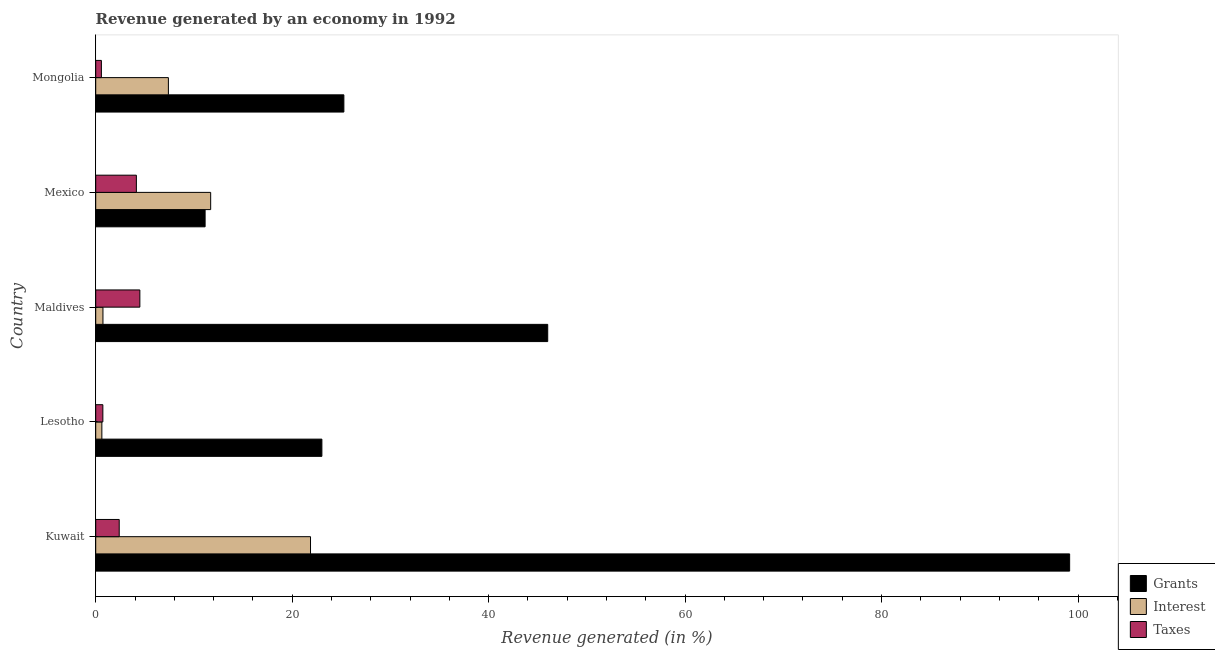How many different coloured bars are there?
Make the answer very short. 3. How many bars are there on the 5th tick from the top?
Your answer should be very brief. 3. How many bars are there on the 5th tick from the bottom?
Offer a terse response. 3. What is the percentage of revenue generated by interest in Lesotho?
Offer a terse response. 0.63. Across all countries, what is the maximum percentage of revenue generated by taxes?
Offer a terse response. 4.49. Across all countries, what is the minimum percentage of revenue generated by taxes?
Keep it short and to the point. 0.58. In which country was the percentage of revenue generated by grants maximum?
Your answer should be very brief. Kuwait. In which country was the percentage of revenue generated by interest minimum?
Your response must be concise. Lesotho. What is the total percentage of revenue generated by taxes in the graph?
Provide a short and direct response. 12.33. What is the difference between the percentage of revenue generated by taxes in Lesotho and that in Maldives?
Your answer should be very brief. -3.77. What is the difference between the percentage of revenue generated by taxes in Kuwait and the percentage of revenue generated by interest in Maldives?
Your answer should be compact. 1.66. What is the average percentage of revenue generated by interest per country?
Give a very brief answer. 8.47. What is the difference between the percentage of revenue generated by interest and percentage of revenue generated by taxes in Maldives?
Your answer should be very brief. -3.76. Is the difference between the percentage of revenue generated by grants in Mexico and Mongolia greater than the difference between the percentage of revenue generated by taxes in Mexico and Mongolia?
Your response must be concise. No. What is the difference between the highest and the second highest percentage of revenue generated by interest?
Offer a very short reply. 10.16. What is the difference between the highest and the lowest percentage of revenue generated by grants?
Give a very brief answer. 88.01. Is the sum of the percentage of revenue generated by grants in Lesotho and Mexico greater than the maximum percentage of revenue generated by taxes across all countries?
Provide a succinct answer. Yes. What does the 1st bar from the top in Kuwait represents?
Offer a very short reply. Taxes. What does the 1st bar from the bottom in Mongolia represents?
Offer a very short reply. Grants. How many bars are there?
Offer a very short reply. 15. Are all the bars in the graph horizontal?
Your response must be concise. Yes. How many countries are there in the graph?
Provide a succinct answer. 5. What is the difference between two consecutive major ticks on the X-axis?
Offer a terse response. 20. Are the values on the major ticks of X-axis written in scientific E-notation?
Ensure brevity in your answer.  No. Does the graph contain any zero values?
Make the answer very short. No. How many legend labels are there?
Provide a short and direct response. 3. What is the title of the graph?
Your answer should be very brief. Revenue generated by an economy in 1992. What is the label or title of the X-axis?
Keep it short and to the point. Revenue generated (in %). What is the Revenue generated (in %) in Grants in Kuwait?
Keep it short and to the point. 99.15. What is the Revenue generated (in %) in Interest in Kuwait?
Make the answer very short. 21.87. What is the Revenue generated (in %) of Taxes in Kuwait?
Make the answer very short. 2.39. What is the Revenue generated (in %) in Grants in Lesotho?
Give a very brief answer. 23.02. What is the Revenue generated (in %) of Interest in Lesotho?
Make the answer very short. 0.63. What is the Revenue generated (in %) in Taxes in Lesotho?
Give a very brief answer. 0.73. What is the Revenue generated (in %) of Grants in Maldives?
Keep it short and to the point. 46.01. What is the Revenue generated (in %) in Interest in Maldives?
Your answer should be compact. 0.74. What is the Revenue generated (in %) in Taxes in Maldives?
Ensure brevity in your answer.  4.49. What is the Revenue generated (in %) in Grants in Mexico?
Give a very brief answer. 11.14. What is the Revenue generated (in %) of Interest in Mexico?
Your response must be concise. 11.7. What is the Revenue generated (in %) in Taxes in Mexico?
Your answer should be very brief. 4.14. What is the Revenue generated (in %) in Grants in Mongolia?
Provide a succinct answer. 25.26. What is the Revenue generated (in %) in Interest in Mongolia?
Keep it short and to the point. 7.4. What is the Revenue generated (in %) of Taxes in Mongolia?
Keep it short and to the point. 0.58. Across all countries, what is the maximum Revenue generated (in %) of Grants?
Provide a short and direct response. 99.15. Across all countries, what is the maximum Revenue generated (in %) in Interest?
Provide a succinct answer. 21.87. Across all countries, what is the maximum Revenue generated (in %) in Taxes?
Provide a short and direct response. 4.49. Across all countries, what is the minimum Revenue generated (in %) in Grants?
Offer a terse response. 11.14. Across all countries, what is the minimum Revenue generated (in %) of Interest?
Your answer should be very brief. 0.63. Across all countries, what is the minimum Revenue generated (in %) of Taxes?
Offer a terse response. 0.58. What is the total Revenue generated (in %) in Grants in the graph?
Your answer should be compact. 204.58. What is the total Revenue generated (in %) in Interest in the graph?
Your answer should be very brief. 42.33. What is the total Revenue generated (in %) of Taxes in the graph?
Provide a short and direct response. 12.33. What is the difference between the Revenue generated (in %) in Grants in Kuwait and that in Lesotho?
Your answer should be compact. 76.12. What is the difference between the Revenue generated (in %) of Interest in Kuwait and that in Lesotho?
Give a very brief answer. 21.24. What is the difference between the Revenue generated (in %) of Taxes in Kuwait and that in Lesotho?
Provide a short and direct response. 1.67. What is the difference between the Revenue generated (in %) of Grants in Kuwait and that in Maldives?
Your response must be concise. 53.13. What is the difference between the Revenue generated (in %) of Interest in Kuwait and that in Maldives?
Offer a terse response. 21.13. What is the difference between the Revenue generated (in %) in Taxes in Kuwait and that in Maldives?
Keep it short and to the point. -2.1. What is the difference between the Revenue generated (in %) of Grants in Kuwait and that in Mexico?
Ensure brevity in your answer.  88.01. What is the difference between the Revenue generated (in %) in Interest in Kuwait and that in Mexico?
Your response must be concise. 10.16. What is the difference between the Revenue generated (in %) of Taxes in Kuwait and that in Mexico?
Provide a short and direct response. -1.75. What is the difference between the Revenue generated (in %) in Grants in Kuwait and that in Mongolia?
Offer a terse response. 73.88. What is the difference between the Revenue generated (in %) of Interest in Kuwait and that in Mongolia?
Make the answer very short. 14.47. What is the difference between the Revenue generated (in %) in Taxes in Kuwait and that in Mongolia?
Give a very brief answer. 1.82. What is the difference between the Revenue generated (in %) in Grants in Lesotho and that in Maldives?
Your answer should be very brief. -22.99. What is the difference between the Revenue generated (in %) of Interest in Lesotho and that in Maldives?
Keep it short and to the point. -0.11. What is the difference between the Revenue generated (in %) in Taxes in Lesotho and that in Maldives?
Keep it short and to the point. -3.77. What is the difference between the Revenue generated (in %) in Grants in Lesotho and that in Mexico?
Make the answer very short. 11.89. What is the difference between the Revenue generated (in %) of Interest in Lesotho and that in Mexico?
Ensure brevity in your answer.  -11.08. What is the difference between the Revenue generated (in %) in Taxes in Lesotho and that in Mexico?
Offer a terse response. -3.41. What is the difference between the Revenue generated (in %) of Grants in Lesotho and that in Mongolia?
Offer a very short reply. -2.24. What is the difference between the Revenue generated (in %) in Interest in Lesotho and that in Mongolia?
Make the answer very short. -6.77. What is the difference between the Revenue generated (in %) in Taxes in Lesotho and that in Mongolia?
Make the answer very short. 0.15. What is the difference between the Revenue generated (in %) in Grants in Maldives and that in Mexico?
Your response must be concise. 34.88. What is the difference between the Revenue generated (in %) of Interest in Maldives and that in Mexico?
Your answer should be very brief. -10.96. What is the difference between the Revenue generated (in %) of Taxes in Maldives and that in Mexico?
Your answer should be very brief. 0.36. What is the difference between the Revenue generated (in %) of Grants in Maldives and that in Mongolia?
Give a very brief answer. 20.75. What is the difference between the Revenue generated (in %) in Interest in Maldives and that in Mongolia?
Your answer should be very brief. -6.66. What is the difference between the Revenue generated (in %) of Taxes in Maldives and that in Mongolia?
Your answer should be very brief. 3.92. What is the difference between the Revenue generated (in %) of Grants in Mexico and that in Mongolia?
Provide a short and direct response. -14.13. What is the difference between the Revenue generated (in %) of Interest in Mexico and that in Mongolia?
Your answer should be very brief. 4.3. What is the difference between the Revenue generated (in %) of Taxes in Mexico and that in Mongolia?
Your response must be concise. 3.56. What is the difference between the Revenue generated (in %) of Grants in Kuwait and the Revenue generated (in %) of Interest in Lesotho?
Your answer should be very brief. 98.52. What is the difference between the Revenue generated (in %) in Grants in Kuwait and the Revenue generated (in %) in Taxes in Lesotho?
Offer a terse response. 98.42. What is the difference between the Revenue generated (in %) of Interest in Kuwait and the Revenue generated (in %) of Taxes in Lesotho?
Ensure brevity in your answer.  21.14. What is the difference between the Revenue generated (in %) of Grants in Kuwait and the Revenue generated (in %) of Interest in Maldives?
Give a very brief answer. 98.41. What is the difference between the Revenue generated (in %) of Grants in Kuwait and the Revenue generated (in %) of Taxes in Maldives?
Offer a very short reply. 94.65. What is the difference between the Revenue generated (in %) in Interest in Kuwait and the Revenue generated (in %) in Taxes in Maldives?
Your answer should be very brief. 17.37. What is the difference between the Revenue generated (in %) in Grants in Kuwait and the Revenue generated (in %) in Interest in Mexico?
Offer a terse response. 87.44. What is the difference between the Revenue generated (in %) in Grants in Kuwait and the Revenue generated (in %) in Taxes in Mexico?
Keep it short and to the point. 95.01. What is the difference between the Revenue generated (in %) of Interest in Kuwait and the Revenue generated (in %) of Taxes in Mexico?
Keep it short and to the point. 17.73. What is the difference between the Revenue generated (in %) of Grants in Kuwait and the Revenue generated (in %) of Interest in Mongolia?
Keep it short and to the point. 91.75. What is the difference between the Revenue generated (in %) of Grants in Kuwait and the Revenue generated (in %) of Taxes in Mongolia?
Provide a short and direct response. 98.57. What is the difference between the Revenue generated (in %) in Interest in Kuwait and the Revenue generated (in %) in Taxes in Mongolia?
Ensure brevity in your answer.  21.29. What is the difference between the Revenue generated (in %) of Grants in Lesotho and the Revenue generated (in %) of Interest in Maldives?
Offer a terse response. 22.29. What is the difference between the Revenue generated (in %) in Grants in Lesotho and the Revenue generated (in %) in Taxes in Maldives?
Provide a short and direct response. 18.53. What is the difference between the Revenue generated (in %) of Interest in Lesotho and the Revenue generated (in %) of Taxes in Maldives?
Offer a terse response. -3.87. What is the difference between the Revenue generated (in %) in Grants in Lesotho and the Revenue generated (in %) in Interest in Mexico?
Give a very brief answer. 11.32. What is the difference between the Revenue generated (in %) in Grants in Lesotho and the Revenue generated (in %) in Taxes in Mexico?
Ensure brevity in your answer.  18.89. What is the difference between the Revenue generated (in %) in Interest in Lesotho and the Revenue generated (in %) in Taxes in Mexico?
Make the answer very short. -3.51. What is the difference between the Revenue generated (in %) of Grants in Lesotho and the Revenue generated (in %) of Interest in Mongolia?
Offer a terse response. 15.63. What is the difference between the Revenue generated (in %) of Grants in Lesotho and the Revenue generated (in %) of Taxes in Mongolia?
Ensure brevity in your answer.  22.45. What is the difference between the Revenue generated (in %) of Interest in Lesotho and the Revenue generated (in %) of Taxes in Mongolia?
Give a very brief answer. 0.05. What is the difference between the Revenue generated (in %) of Grants in Maldives and the Revenue generated (in %) of Interest in Mexico?
Offer a very short reply. 34.31. What is the difference between the Revenue generated (in %) in Grants in Maldives and the Revenue generated (in %) in Taxes in Mexico?
Ensure brevity in your answer.  41.88. What is the difference between the Revenue generated (in %) of Interest in Maldives and the Revenue generated (in %) of Taxes in Mexico?
Provide a short and direct response. -3.4. What is the difference between the Revenue generated (in %) in Grants in Maldives and the Revenue generated (in %) in Interest in Mongolia?
Keep it short and to the point. 38.62. What is the difference between the Revenue generated (in %) in Grants in Maldives and the Revenue generated (in %) in Taxes in Mongolia?
Give a very brief answer. 45.44. What is the difference between the Revenue generated (in %) in Interest in Maldives and the Revenue generated (in %) in Taxes in Mongolia?
Provide a short and direct response. 0.16. What is the difference between the Revenue generated (in %) of Grants in Mexico and the Revenue generated (in %) of Interest in Mongolia?
Provide a succinct answer. 3.74. What is the difference between the Revenue generated (in %) of Grants in Mexico and the Revenue generated (in %) of Taxes in Mongolia?
Ensure brevity in your answer.  10.56. What is the difference between the Revenue generated (in %) of Interest in Mexico and the Revenue generated (in %) of Taxes in Mongolia?
Your answer should be very brief. 11.12. What is the average Revenue generated (in %) of Grants per country?
Your answer should be compact. 40.92. What is the average Revenue generated (in %) in Interest per country?
Your answer should be compact. 8.47. What is the average Revenue generated (in %) of Taxes per country?
Your response must be concise. 2.47. What is the difference between the Revenue generated (in %) of Grants and Revenue generated (in %) of Interest in Kuwait?
Provide a short and direct response. 77.28. What is the difference between the Revenue generated (in %) of Grants and Revenue generated (in %) of Taxes in Kuwait?
Provide a succinct answer. 96.75. What is the difference between the Revenue generated (in %) of Interest and Revenue generated (in %) of Taxes in Kuwait?
Ensure brevity in your answer.  19.47. What is the difference between the Revenue generated (in %) in Grants and Revenue generated (in %) in Interest in Lesotho?
Your response must be concise. 22.4. What is the difference between the Revenue generated (in %) of Grants and Revenue generated (in %) of Taxes in Lesotho?
Keep it short and to the point. 22.3. What is the difference between the Revenue generated (in %) in Interest and Revenue generated (in %) in Taxes in Lesotho?
Your answer should be compact. -0.1. What is the difference between the Revenue generated (in %) of Grants and Revenue generated (in %) of Interest in Maldives?
Your answer should be very brief. 45.28. What is the difference between the Revenue generated (in %) in Grants and Revenue generated (in %) in Taxes in Maldives?
Offer a very short reply. 41.52. What is the difference between the Revenue generated (in %) of Interest and Revenue generated (in %) of Taxes in Maldives?
Offer a very short reply. -3.76. What is the difference between the Revenue generated (in %) of Grants and Revenue generated (in %) of Interest in Mexico?
Give a very brief answer. -0.57. What is the difference between the Revenue generated (in %) of Grants and Revenue generated (in %) of Taxes in Mexico?
Provide a succinct answer. 7. What is the difference between the Revenue generated (in %) in Interest and Revenue generated (in %) in Taxes in Mexico?
Give a very brief answer. 7.56. What is the difference between the Revenue generated (in %) of Grants and Revenue generated (in %) of Interest in Mongolia?
Provide a succinct answer. 17.86. What is the difference between the Revenue generated (in %) of Grants and Revenue generated (in %) of Taxes in Mongolia?
Your response must be concise. 24.68. What is the difference between the Revenue generated (in %) of Interest and Revenue generated (in %) of Taxes in Mongolia?
Your answer should be very brief. 6.82. What is the ratio of the Revenue generated (in %) of Grants in Kuwait to that in Lesotho?
Offer a very short reply. 4.31. What is the ratio of the Revenue generated (in %) of Interest in Kuwait to that in Lesotho?
Give a very brief answer. 34.9. What is the ratio of the Revenue generated (in %) of Taxes in Kuwait to that in Lesotho?
Your response must be concise. 3.29. What is the ratio of the Revenue generated (in %) of Grants in Kuwait to that in Maldives?
Provide a succinct answer. 2.15. What is the ratio of the Revenue generated (in %) in Interest in Kuwait to that in Maldives?
Ensure brevity in your answer.  29.65. What is the ratio of the Revenue generated (in %) of Taxes in Kuwait to that in Maldives?
Your response must be concise. 0.53. What is the ratio of the Revenue generated (in %) in Grants in Kuwait to that in Mexico?
Offer a terse response. 8.9. What is the ratio of the Revenue generated (in %) of Interest in Kuwait to that in Mexico?
Keep it short and to the point. 1.87. What is the ratio of the Revenue generated (in %) of Taxes in Kuwait to that in Mexico?
Offer a terse response. 0.58. What is the ratio of the Revenue generated (in %) in Grants in Kuwait to that in Mongolia?
Your answer should be compact. 3.92. What is the ratio of the Revenue generated (in %) of Interest in Kuwait to that in Mongolia?
Provide a succinct answer. 2.96. What is the ratio of the Revenue generated (in %) in Taxes in Kuwait to that in Mongolia?
Make the answer very short. 4.14. What is the ratio of the Revenue generated (in %) of Grants in Lesotho to that in Maldives?
Your answer should be compact. 0.5. What is the ratio of the Revenue generated (in %) of Interest in Lesotho to that in Maldives?
Your response must be concise. 0.85. What is the ratio of the Revenue generated (in %) in Taxes in Lesotho to that in Maldives?
Your response must be concise. 0.16. What is the ratio of the Revenue generated (in %) of Grants in Lesotho to that in Mexico?
Your answer should be compact. 2.07. What is the ratio of the Revenue generated (in %) of Interest in Lesotho to that in Mexico?
Make the answer very short. 0.05. What is the ratio of the Revenue generated (in %) in Taxes in Lesotho to that in Mexico?
Offer a terse response. 0.18. What is the ratio of the Revenue generated (in %) in Grants in Lesotho to that in Mongolia?
Offer a very short reply. 0.91. What is the ratio of the Revenue generated (in %) in Interest in Lesotho to that in Mongolia?
Offer a very short reply. 0.08. What is the ratio of the Revenue generated (in %) in Taxes in Lesotho to that in Mongolia?
Give a very brief answer. 1.26. What is the ratio of the Revenue generated (in %) of Grants in Maldives to that in Mexico?
Your answer should be compact. 4.13. What is the ratio of the Revenue generated (in %) of Interest in Maldives to that in Mexico?
Your answer should be very brief. 0.06. What is the ratio of the Revenue generated (in %) of Taxes in Maldives to that in Mexico?
Offer a very short reply. 1.09. What is the ratio of the Revenue generated (in %) of Grants in Maldives to that in Mongolia?
Give a very brief answer. 1.82. What is the ratio of the Revenue generated (in %) in Interest in Maldives to that in Mongolia?
Make the answer very short. 0.1. What is the ratio of the Revenue generated (in %) of Taxes in Maldives to that in Mongolia?
Offer a terse response. 7.77. What is the ratio of the Revenue generated (in %) of Grants in Mexico to that in Mongolia?
Offer a terse response. 0.44. What is the ratio of the Revenue generated (in %) of Interest in Mexico to that in Mongolia?
Your answer should be compact. 1.58. What is the ratio of the Revenue generated (in %) of Taxes in Mexico to that in Mongolia?
Ensure brevity in your answer.  7.16. What is the difference between the highest and the second highest Revenue generated (in %) of Grants?
Provide a succinct answer. 53.13. What is the difference between the highest and the second highest Revenue generated (in %) of Interest?
Provide a succinct answer. 10.16. What is the difference between the highest and the second highest Revenue generated (in %) of Taxes?
Keep it short and to the point. 0.36. What is the difference between the highest and the lowest Revenue generated (in %) in Grants?
Your response must be concise. 88.01. What is the difference between the highest and the lowest Revenue generated (in %) in Interest?
Keep it short and to the point. 21.24. What is the difference between the highest and the lowest Revenue generated (in %) in Taxes?
Offer a very short reply. 3.92. 